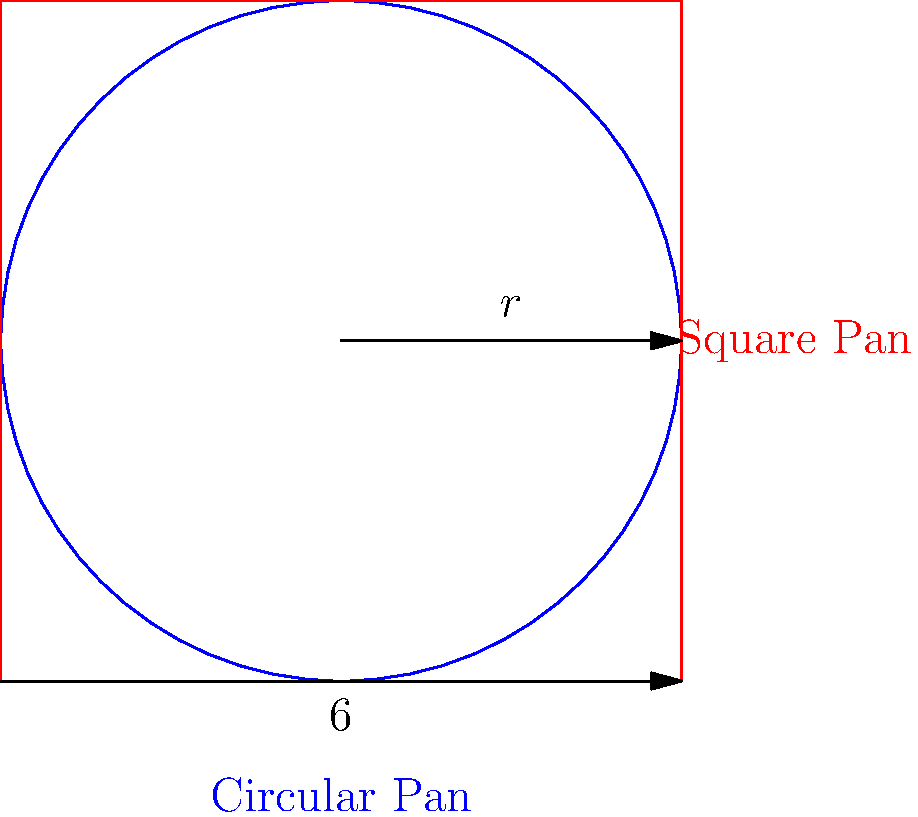You're preparing to bake a cake and have two pans: a circular pan with a radius of 9 inches and a square pan with sides of 16 inches. Which pan has a larger area for your cake, and by how much? Let's approach this step-by-step:

1. Calculate the area of the circular pan:
   The formula for the area of a circle is $A = \pi r^2$
   $A_{circle} = \pi \cdot 9^2 = 81\pi \approx 254.47$ square inches

2. Calculate the area of the square pan:
   The formula for the area of a square is $A = s^2$, where $s$ is the side length
   $A_{square} = 16^2 = 256$ square inches

3. Compare the areas:
   $A_{square} - A_{circle} = 256 - 254.47 = 1.53$ square inches

4. Calculate the percentage difference:
   Percentage difference = $\frac{\text{Difference}}{\text{Average}} \times 100\%$
   $= \frac{1.53}{\frac{256 + 254.47}{2}} \times 100\% \approx 0.60\%$

Therefore, the square pan has a slightly larger area, by about 1.53 square inches or 0.60%.
Answer: The square pan is larger by 1.53 square inches (0.60%). 